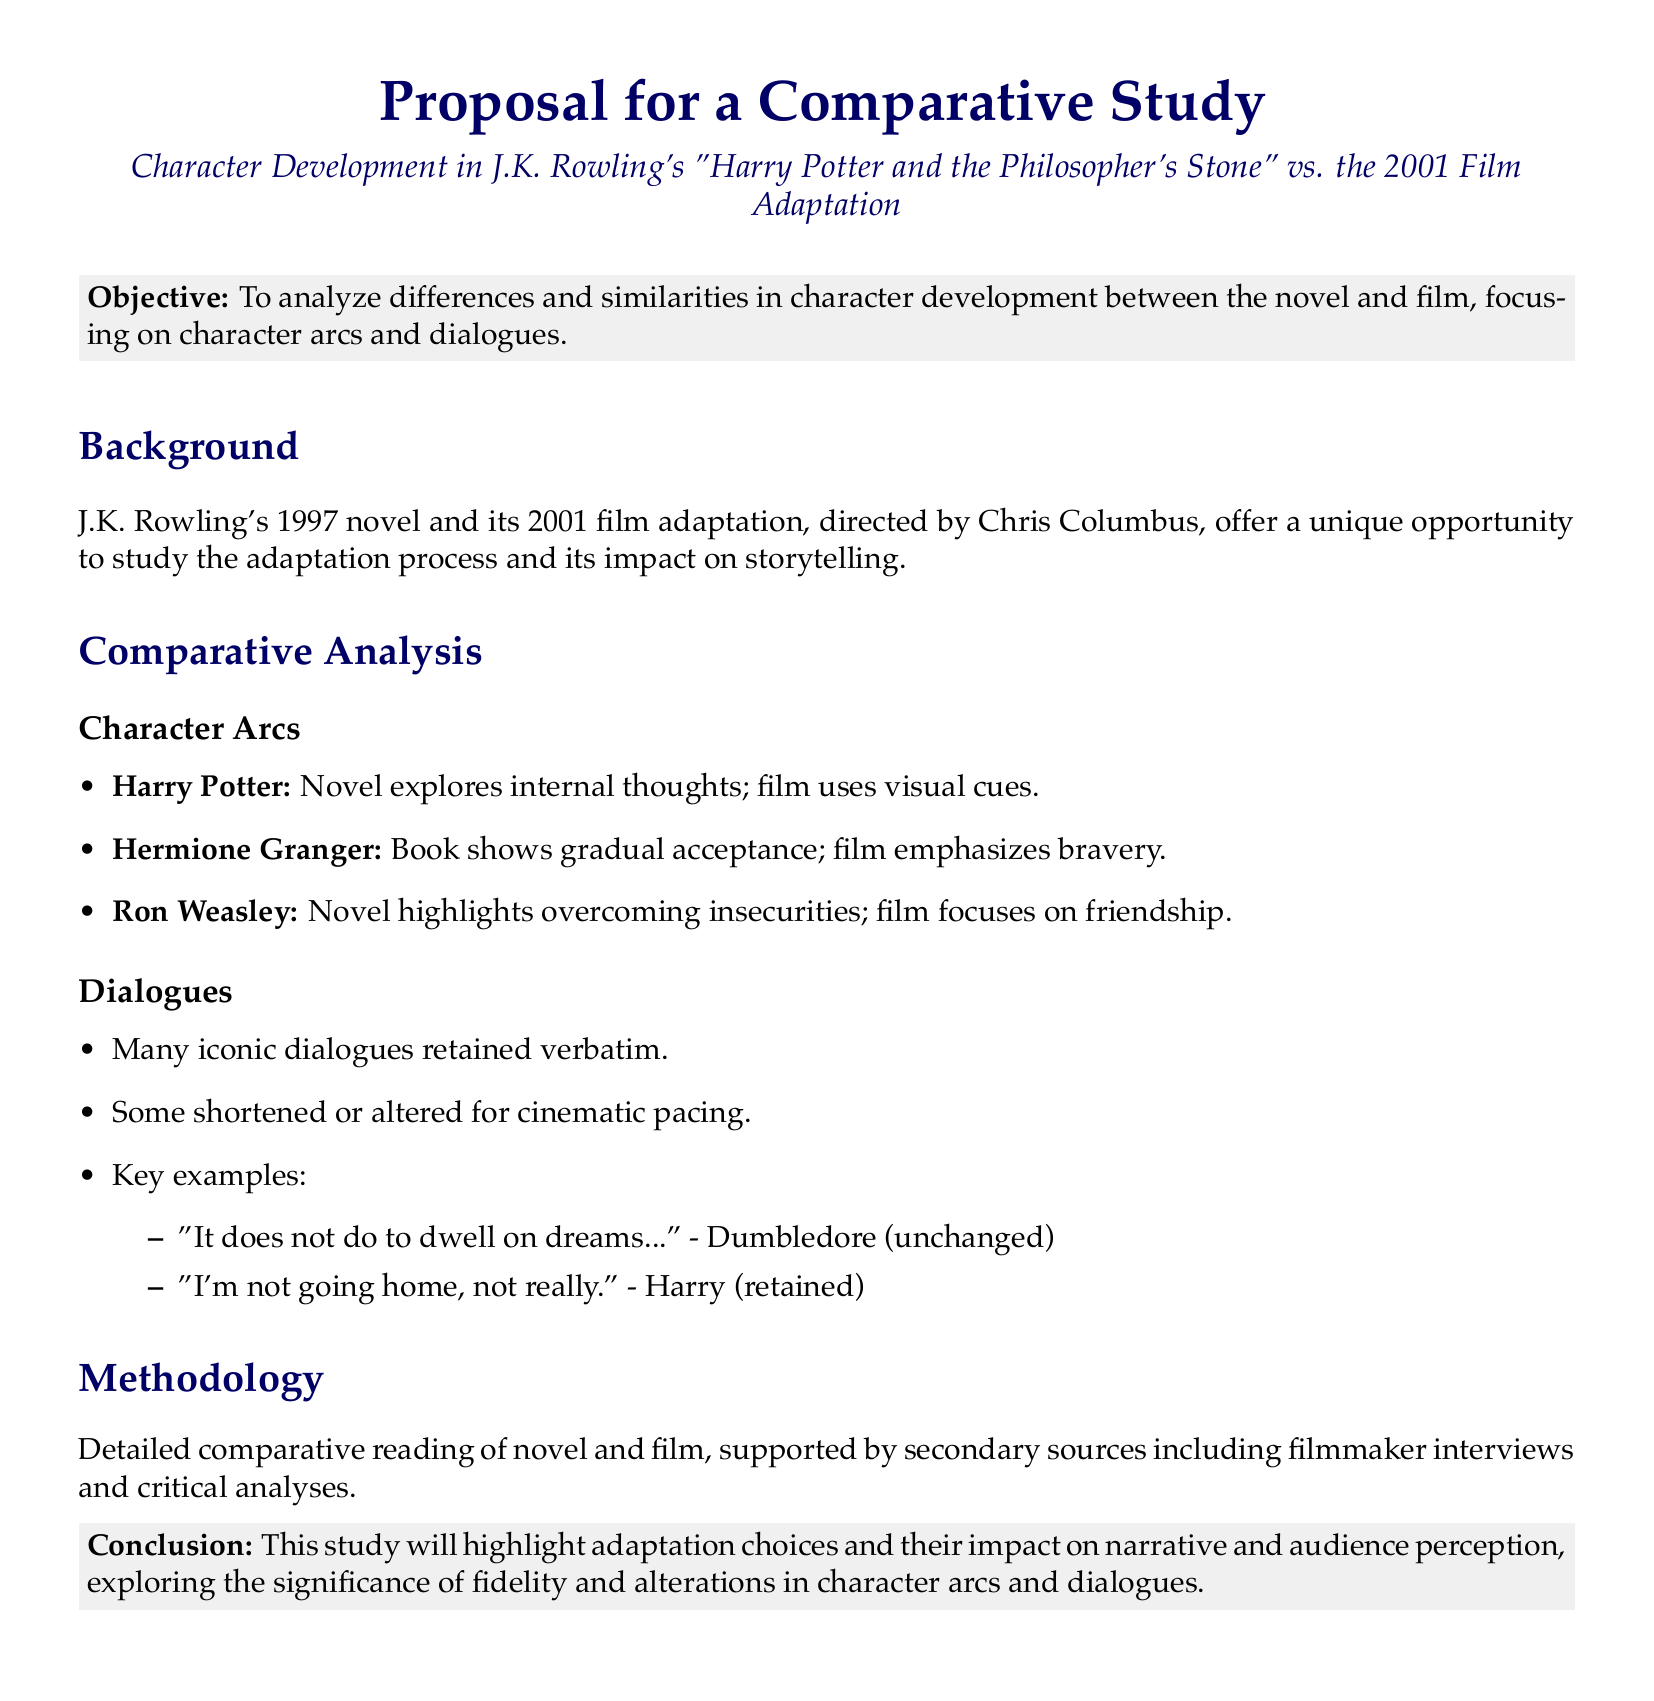What is the main objective of the proposal? The main objective is to analyze differences and similarities in character development between the novel and film, focusing on character arcs and dialogues.
Answer: To analyze differences and similarities in character development What year was the novel "Harry Potter and the Philosopher's Stone" published? The novel was published in 1997, as stated in the background section of the proposal.
Answer: 1997 Who directed the 2001 film adaptation? The director's name is mentioned in the background section.
Answer: Chris Columbus Which character's arc emphasizes bravery in the film? The comparative analysis section indicates that Hermione Granger's arc emphasizes bravery in the film.
Answer: Hermione Granger What is one of the iconic dialogues retained verbatim in the film? The document lists dialogues and notes some were retained verbatim; one of them is provided as an example.
Answer: "It does not do to dwell on dreams..." What does the methodology section primarily include? The methodology section describes conducting a detailed comparative reading of the novel and film.
Answer: Detailed comparative reading How many years apart were the novel and film released? The difference in release years is calculated from 1997 and 2001.
Answer: 4 years What does the conclusion aim to highlight? The conclusion suggests that the study will highlight adaptation choices and their impact on narrative and audience perception.
Answer: Adaptation choices and their impact on narrative 